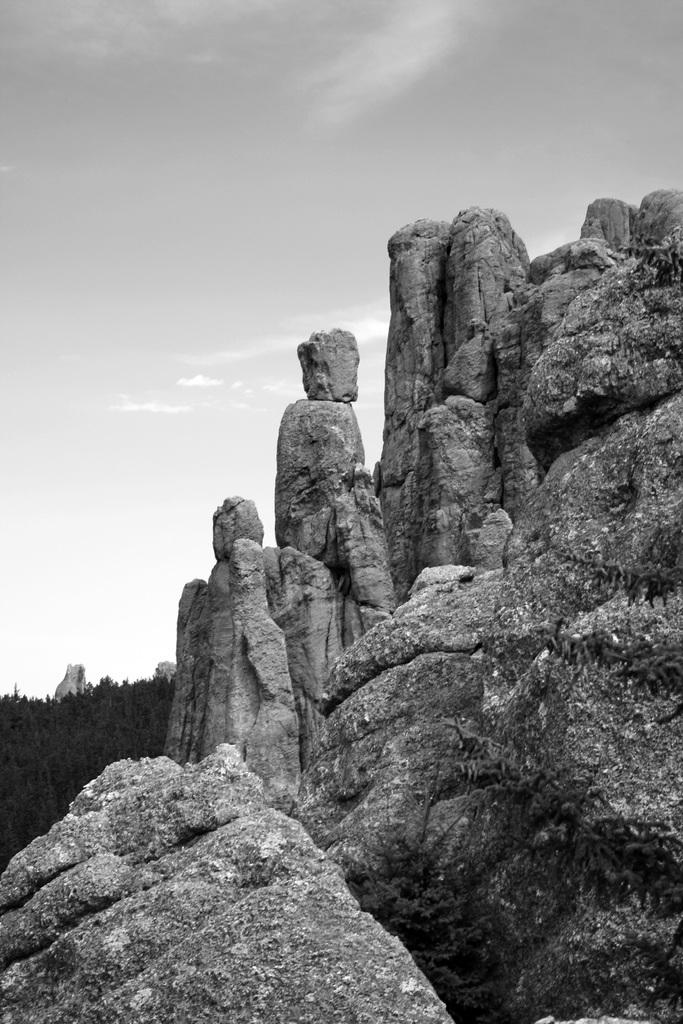What type of natural landform can be seen in the right corner of the image? There are mountains in the right corner of the image. What type of vegetation is present in the left corner of the image? There are trees in the left corner of the image. How many oranges are hanging from the trees in the image? There are no oranges present in the image; it features trees without any fruit. Can you describe the facial expression of the trees in the image? Trees do not have facial expressions, so it is not possible to describe a smile or any other expression on their "faces." 